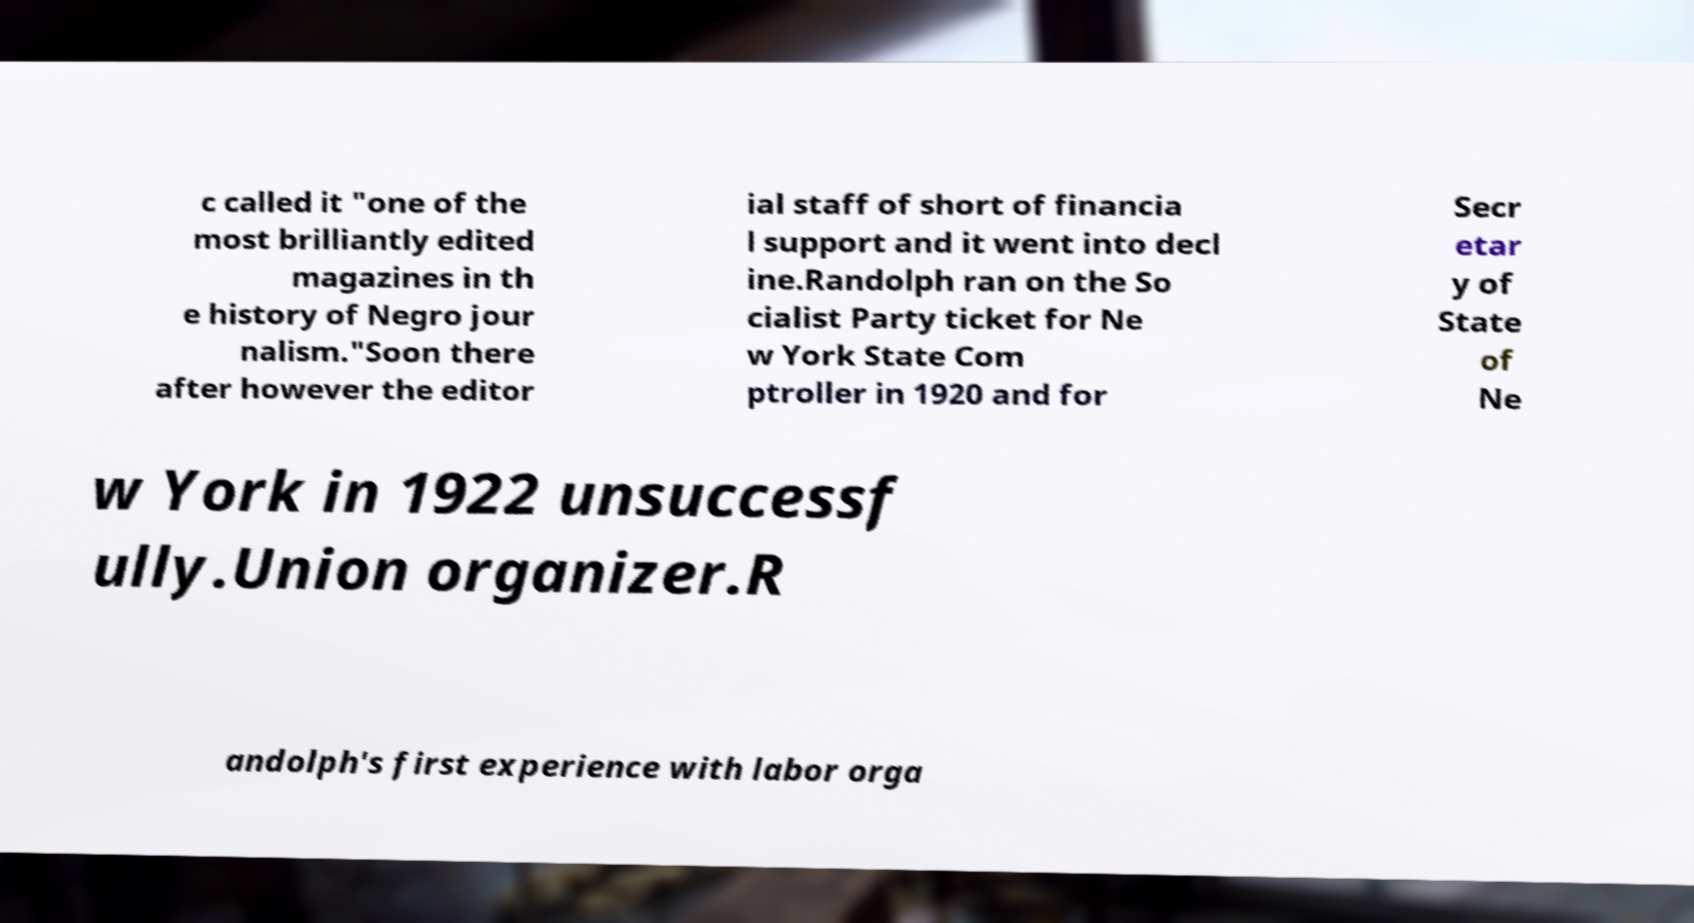Could you assist in decoding the text presented in this image and type it out clearly? c called it "one of the most brilliantly edited magazines in th e history of Negro jour nalism."Soon there after however the editor ial staff of short of financia l support and it went into decl ine.Randolph ran on the So cialist Party ticket for Ne w York State Com ptroller in 1920 and for Secr etar y of State of Ne w York in 1922 unsuccessf ully.Union organizer.R andolph's first experience with labor orga 